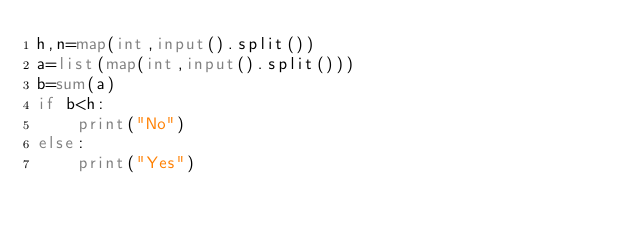Convert code to text. <code><loc_0><loc_0><loc_500><loc_500><_Python_>h,n=map(int,input().split())
a=list(map(int,input().split()))
b=sum(a)
if b<h:
    print("No")
else:
    print("Yes")
</code> 